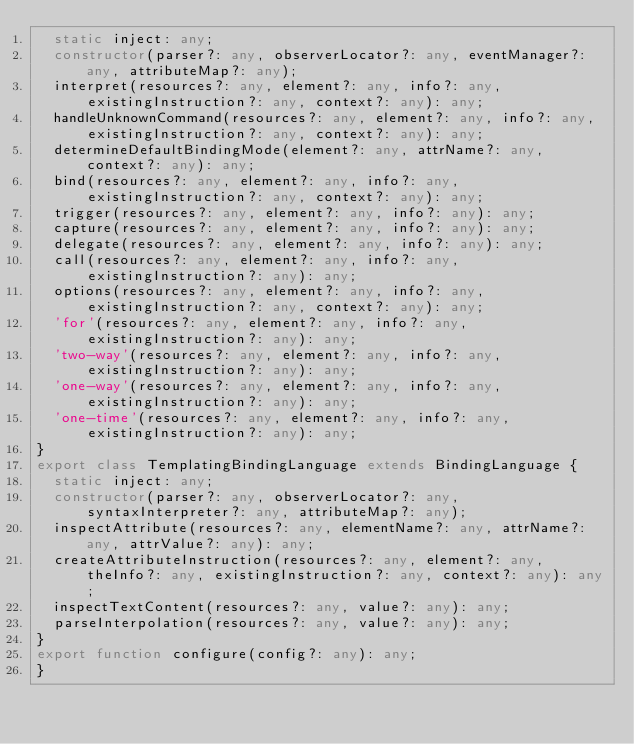Convert code to text. <code><loc_0><loc_0><loc_500><loc_500><_TypeScript_>  static inject: any;
  constructor(parser?: any, observerLocator?: any, eventManager?: any, attributeMap?: any);
  interpret(resources?: any, element?: any, info?: any, existingInstruction?: any, context?: any): any;
  handleUnknownCommand(resources?: any, element?: any, info?: any, existingInstruction?: any, context?: any): any;
  determineDefaultBindingMode(element?: any, attrName?: any, context?: any): any;
  bind(resources?: any, element?: any, info?: any, existingInstruction?: any, context?: any): any;
  trigger(resources?: any, element?: any, info?: any): any;
  capture(resources?: any, element?: any, info?: any): any;
  delegate(resources?: any, element?: any, info?: any): any;
  call(resources?: any, element?: any, info?: any, existingInstruction?: any): any;
  options(resources?: any, element?: any, info?: any, existingInstruction?: any, context?: any): any;
  'for'(resources?: any, element?: any, info?: any, existingInstruction?: any): any;
  'two-way'(resources?: any, element?: any, info?: any, existingInstruction?: any): any;
  'one-way'(resources?: any, element?: any, info?: any, existingInstruction?: any): any;
  'one-time'(resources?: any, element?: any, info?: any, existingInstruction?: any): any;
}
export class TemplatingBindingLanguage extends BindingLanguage {
  static inject: any;
  constructor(parser?: any, observerLocator?: any, syntaxInterpreter?: any, attributeMap?: any);
  inspectAttribute(resources?: any, elementName?: any, attrName?: any, attrValue?: any): any;
  createAttributeInstruction(resources?: any, element?: any, theInfo?: any, existingInstruction?: any, context?: any): any;
  inspectTextContent(resources?: any, value?: any): any;
  parseInterpolation(resources?: any, value?: any): any;
}
export function configure(config?: any): any;
}
</code> 